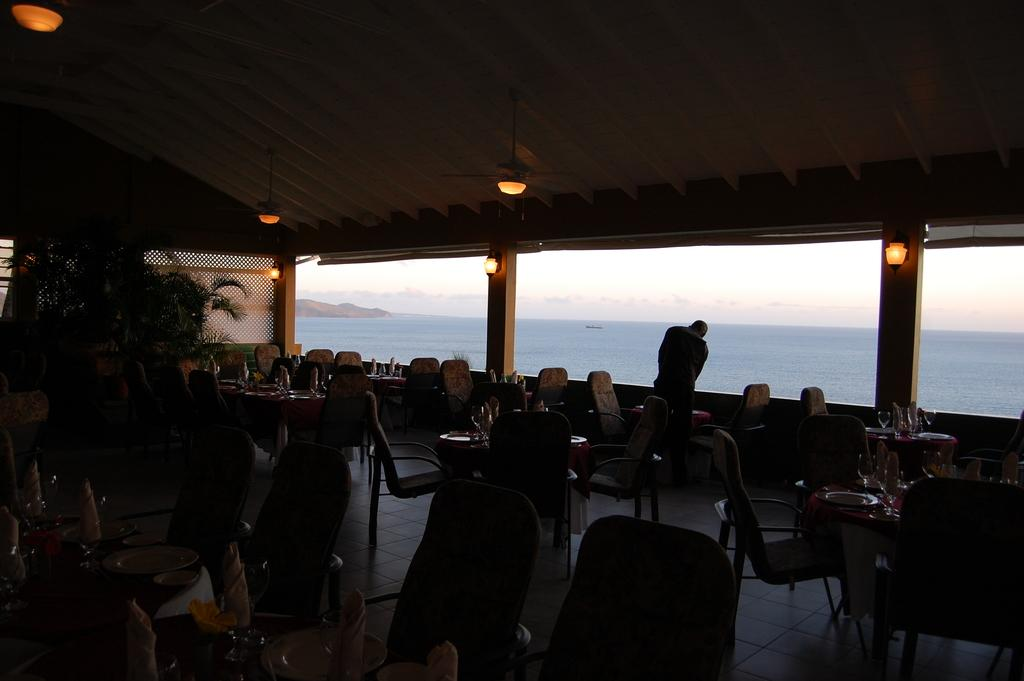What type of furniture is present in the image? There is a table and a chair in the image. What is placed on the table? There is a plate, a spoon, and a cloth on the table. What can be seen in the background of the image? Water is visible in the background. Is there a person in the image? Yes, there is a person standing in the image. How many frogs are jumping on the table in the image? There are no frogs present in the image; it only features a table, a chair, a plate, a spoon, a cloth, water in the background, and a person standing. What type of hose is being used by the person in the image? There is no hose visible in the image; the person is simply standing. 